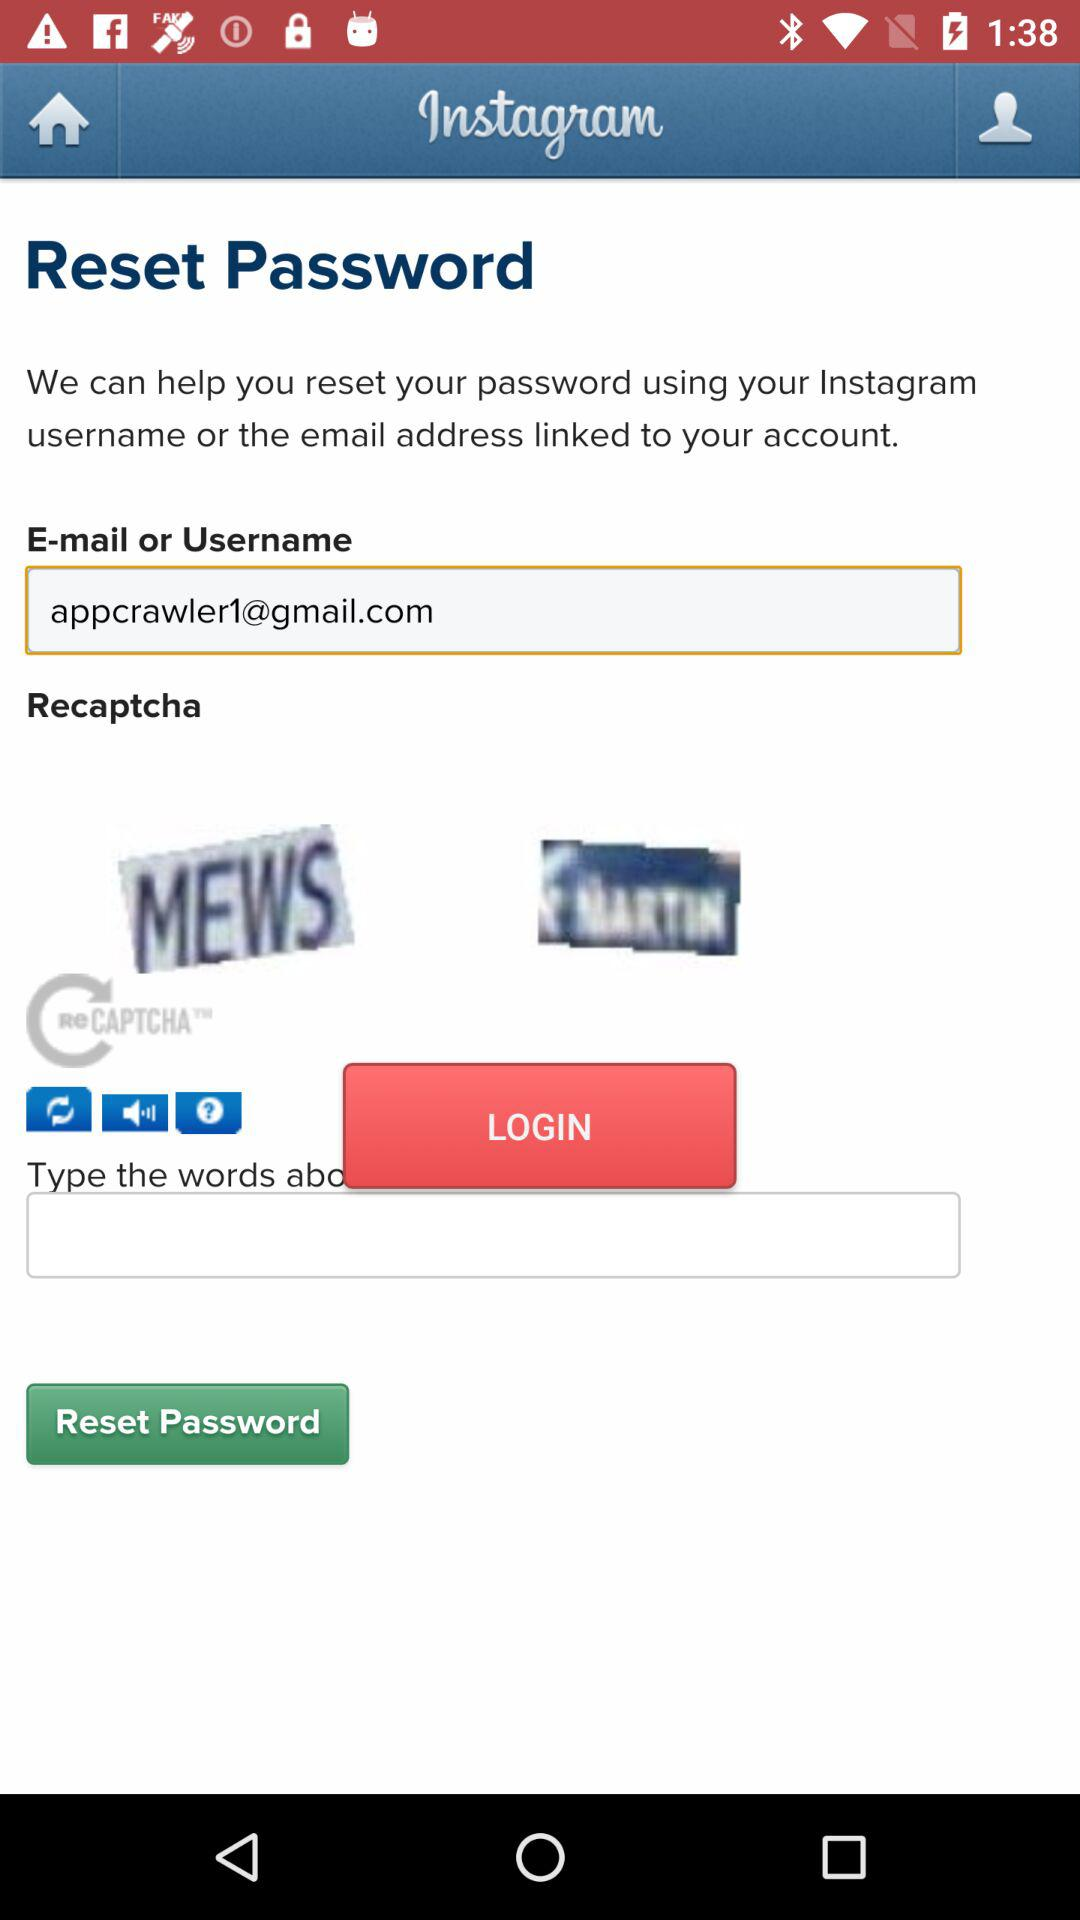What is the user's email address? The user's email address is appcrawler1@gmail.com. 